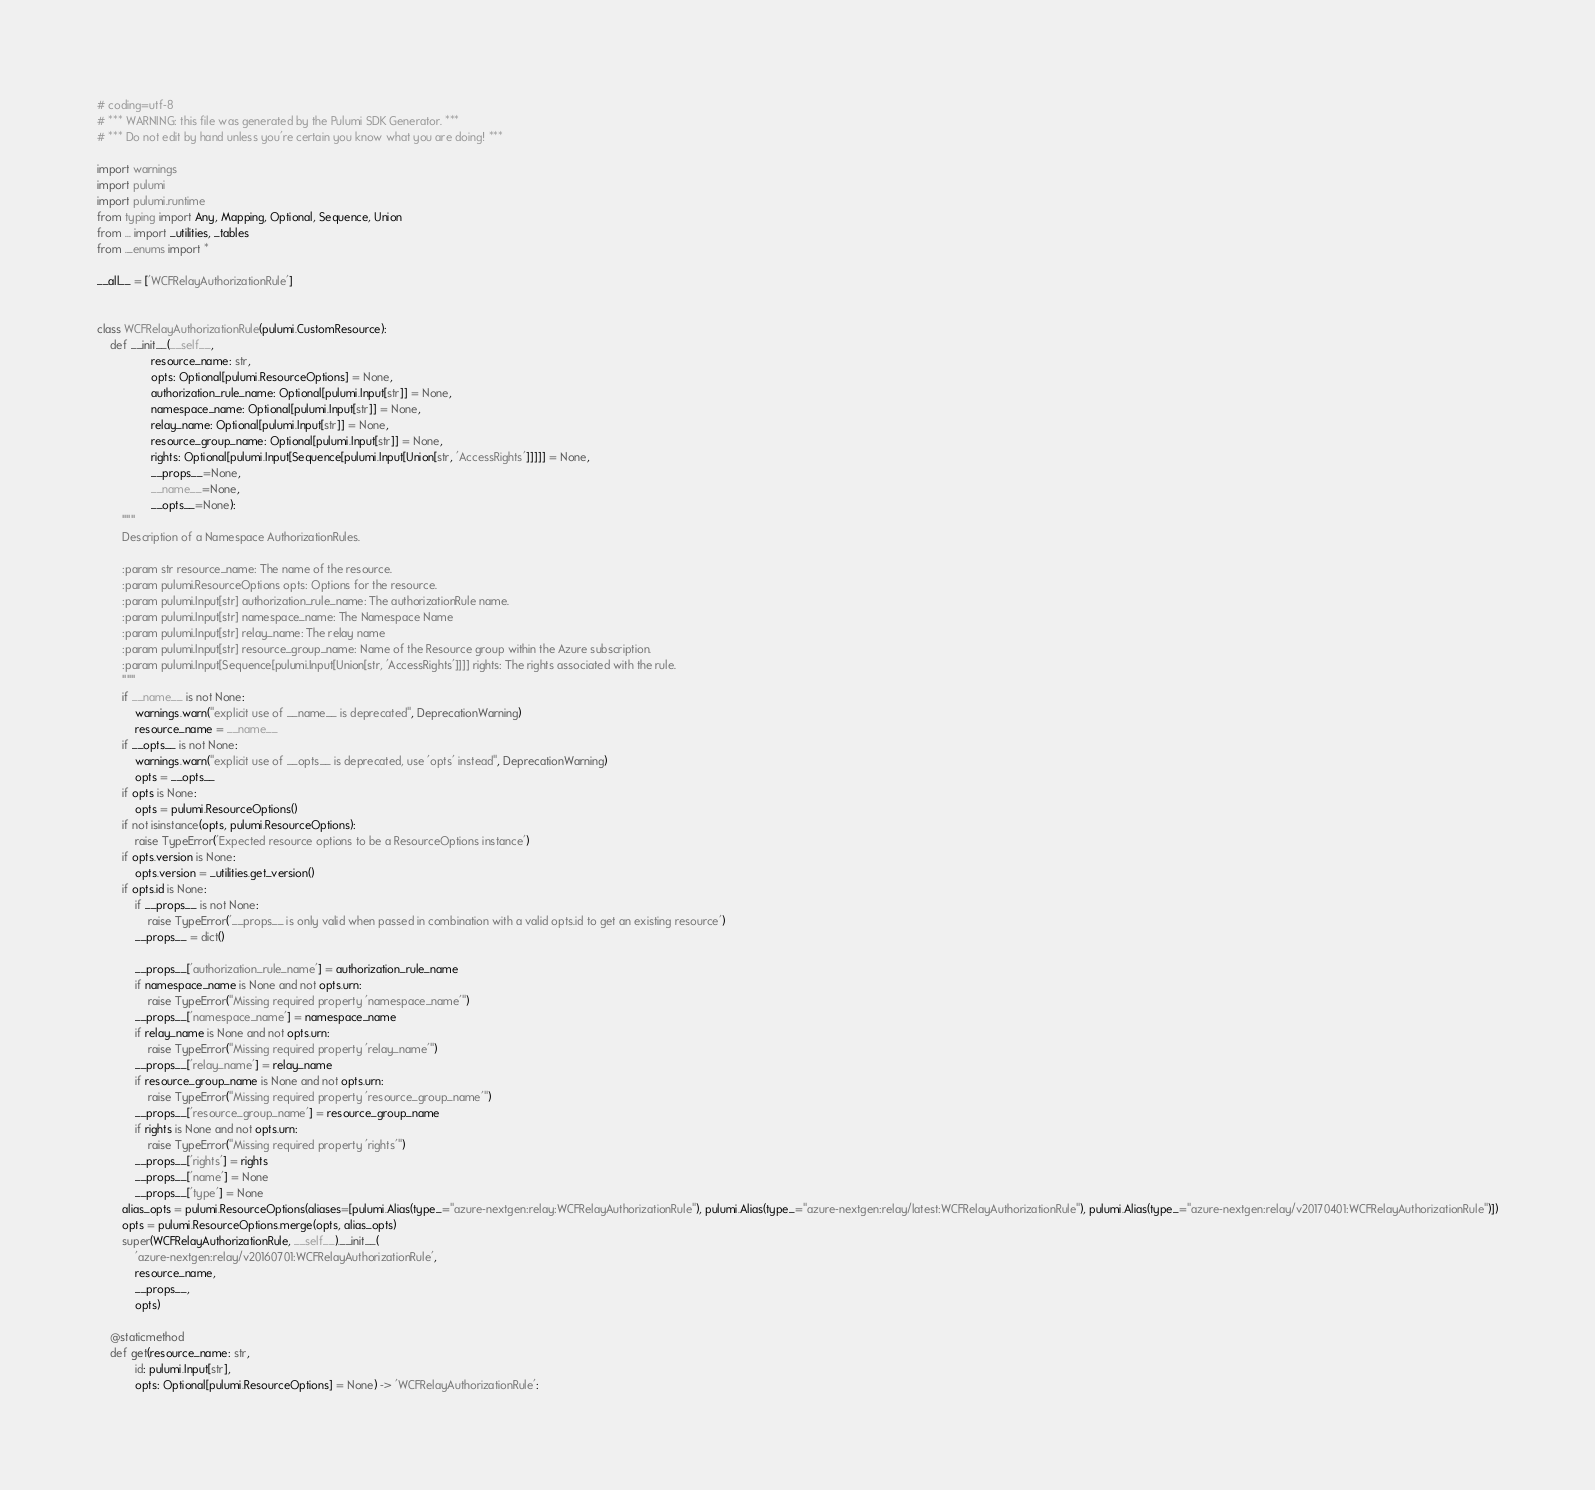<code> <loc_0><loc_0><loc_500><loc_500><_Python_># coding=utf-8
# *** WARNING: this file was generated by the Pulumi SDK Generator. ***
# *** Do not edit by hand unless you're certain you know what you are doing! ***

import warnings
import pulumi
import pulumi.runtime
from typing import Any, Mapping, Optional, Sequence, Union
from ... import _utilities, _tables
from ._enums import *

__all__ = ['WCFRelayAuthorizationRule']


class WCFRelayAuthorizationRule(pulumi.CustomResource):
    def __init__(__self__,
                 resource_name: str,
                 opts: Optional[pulumi.ResourceOptions] = None,
                 authorization_rule_name: Optional[pulumi.Input[str]] = None,
                 namespace_name: Optional[pulumi.Input[str]] = None,
                 relay_name: Optional[pulumi.Input[str]] = None,
                 resource_group_name: Optional[pulumi.Input[str]] = None,
                 rights: Optional[pulumi.Input[Sequence[pulumi.Input[Union[str, 'AccessRights']]]]] = None,
                 __props__=None,
                 __name__=None,
                 __opts__=None):
        """
        Description of a Namespace AuthorizationRules.

        :param str resource_name: The name of the resource.
        :param pulumi.ResourceOptions opts: Options for the resource.
        :param pulumi.Input[str] authorization_rule_name: The authorizationRule name.
        :param pulumi.Input[str] namespace_name: The Namespace Name
        :param pulumi.Input[str] relay_name: The relay name
        :param pulumi.Input[str] resource_group_name: Name of the Resource group within the Azure subscription.
        :param pulumi.Input[Sequence[pulumi.Input[Union[str, 'AccessRights']]]] rights: The rights associated with the rule.
        """
        if __name__ is not None:
            warnings.warn("explicit use of __name__ is deprecated", DeprecationWarning)
            resource_name = __name__
        if __opts__ is not None:
            warnings.warn("explicit use of __opts__ is deprecated, use 'opts' instead", DeprecationWarning)
            opts = __opts__
        if opts is None:
            opts = pulumi.ResourceOptions()
        if not isinstance(opts, pulumi.ResourceOptions):
            raise TypeError('Expected resource options to be a ResourceOptions instance')
        if opts.version is None:
            opts.version = _utilities.get_version()
        if opts.id is None:
            if __props__ is not None:
                raise TypeError('__props__ is only valid when passed in combination with a valid opts.id to get an existing resource')
            __props__ = dict()

            __props__['authorization_rule_name'] = authorization_rule_name
            if namespace_name is None and not opts.urn:
                raise TypeError("Missing required property 'namespace_name'")
            __props__['namespace_name'] = namespace_name
            if relay_name is None and not opts.urn:
                raise TypeError("Missing required property 'relay_name'")
            __props__['relay_name'] = relay_name
            if resource_group_name is None and not opts.urn:
                raise TypeError("Missing required property 'resource_group_name'")
            __props__['resource_group_name'] = resource_group_name
            if rights is None and not opts.urn:
                raise TypeError("Missing required property 'rights'")
            __props__['rights'] = rights
            __props__['name'] = None
            __props__['type'] = None
        alias_opts = pulumi.ResourceOptions(aliases=[pulumi.Alias(type_="azure-nextgen:relay:WCFRelayAuthorizationRule"), pulumi.Alias(type_="azure-nextgen:relay/latest:WCFRelayAuthorizationRule"), pulumi.Alias(type_="azure-nextgen:relay/v20170401:WCFRelayAuthorizationRule")])
        opts = pulumi.ResourceOptions.merge(opts, alias_opts)
        super(WCFRelayAuthorizationRule, __self__).__init__(
            'azure-nextgen:relay/v20160701:WCFRelayAuthorizationRule',
            resource_name,
            __props__,
            opts)

    @staticmethod
    def get(resource_name: str,
            id: pulumi.Input[str],
            opts: Optional[pulumi.ResourceOptions] = None) -> 'WCFRelayAuthorizationRule':</code> 